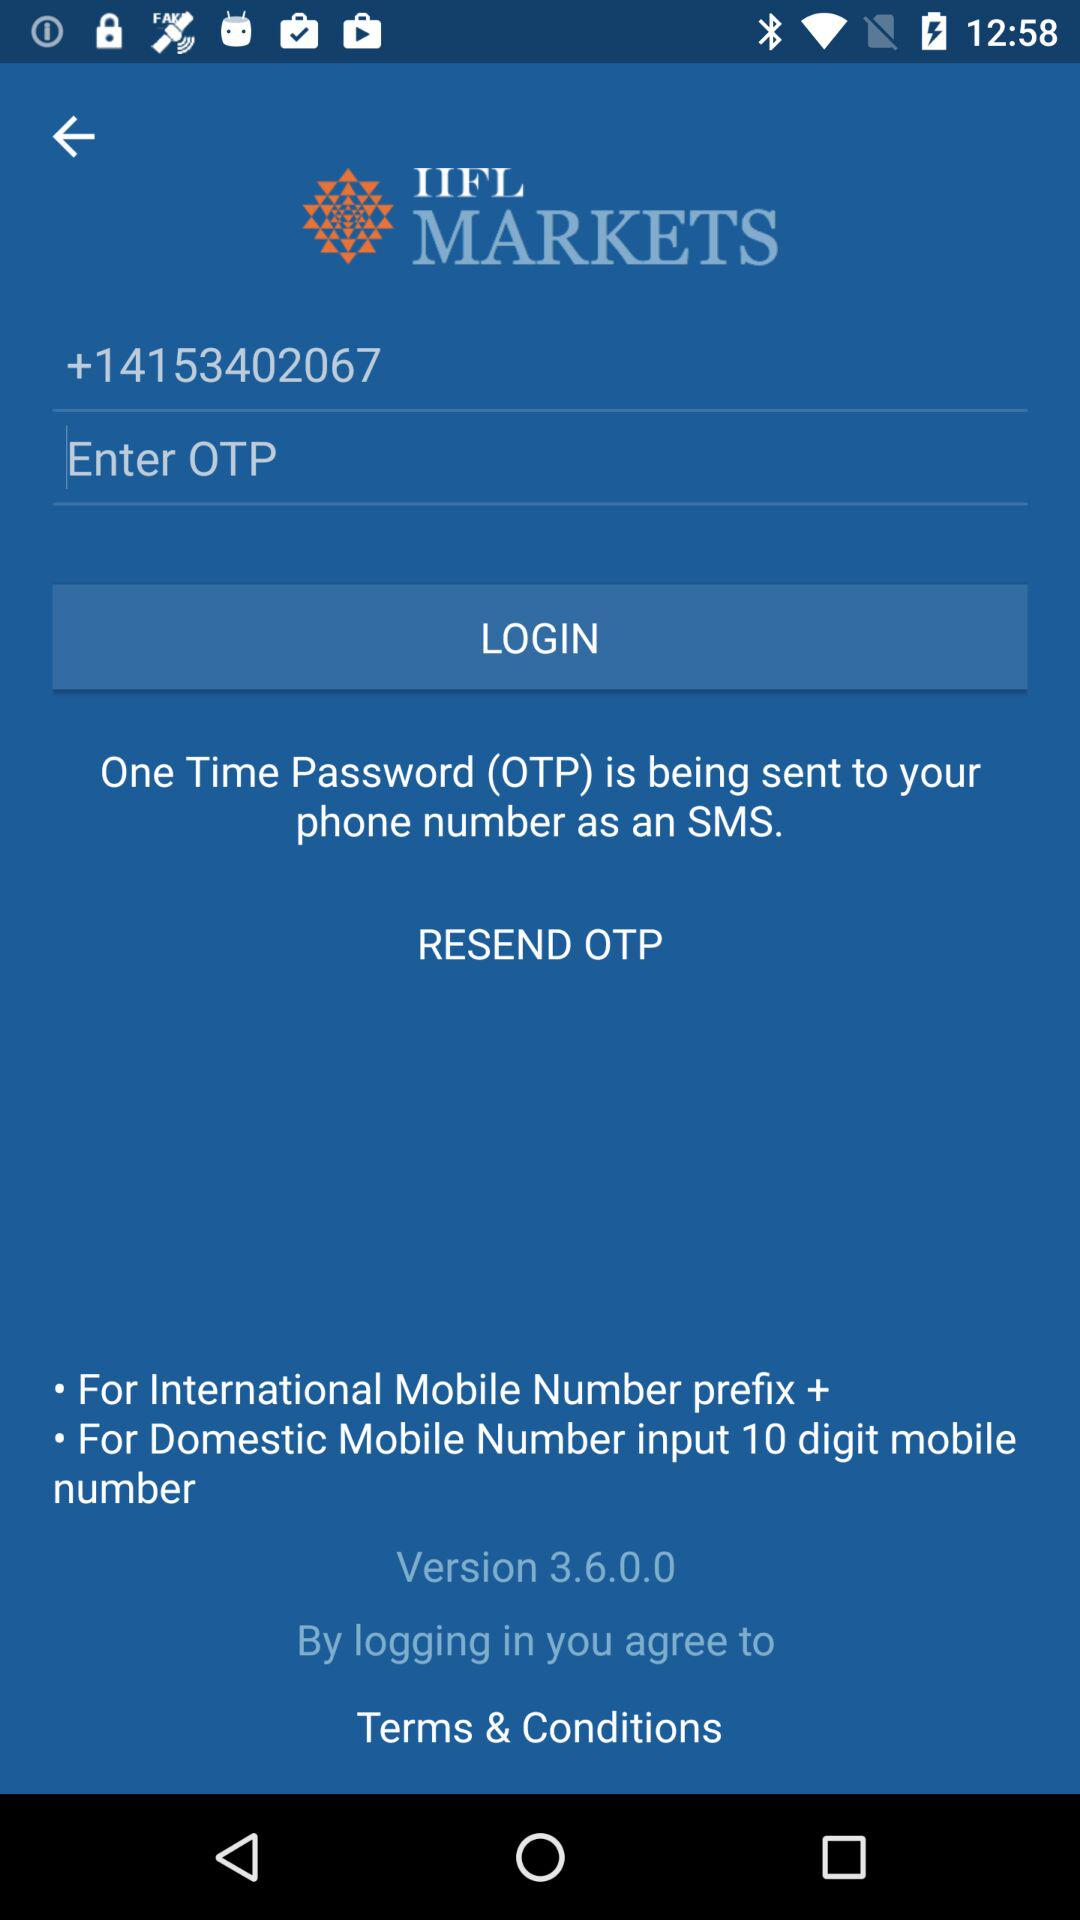What is the name of the application? The name of the application is "IIFL MARKETS". 